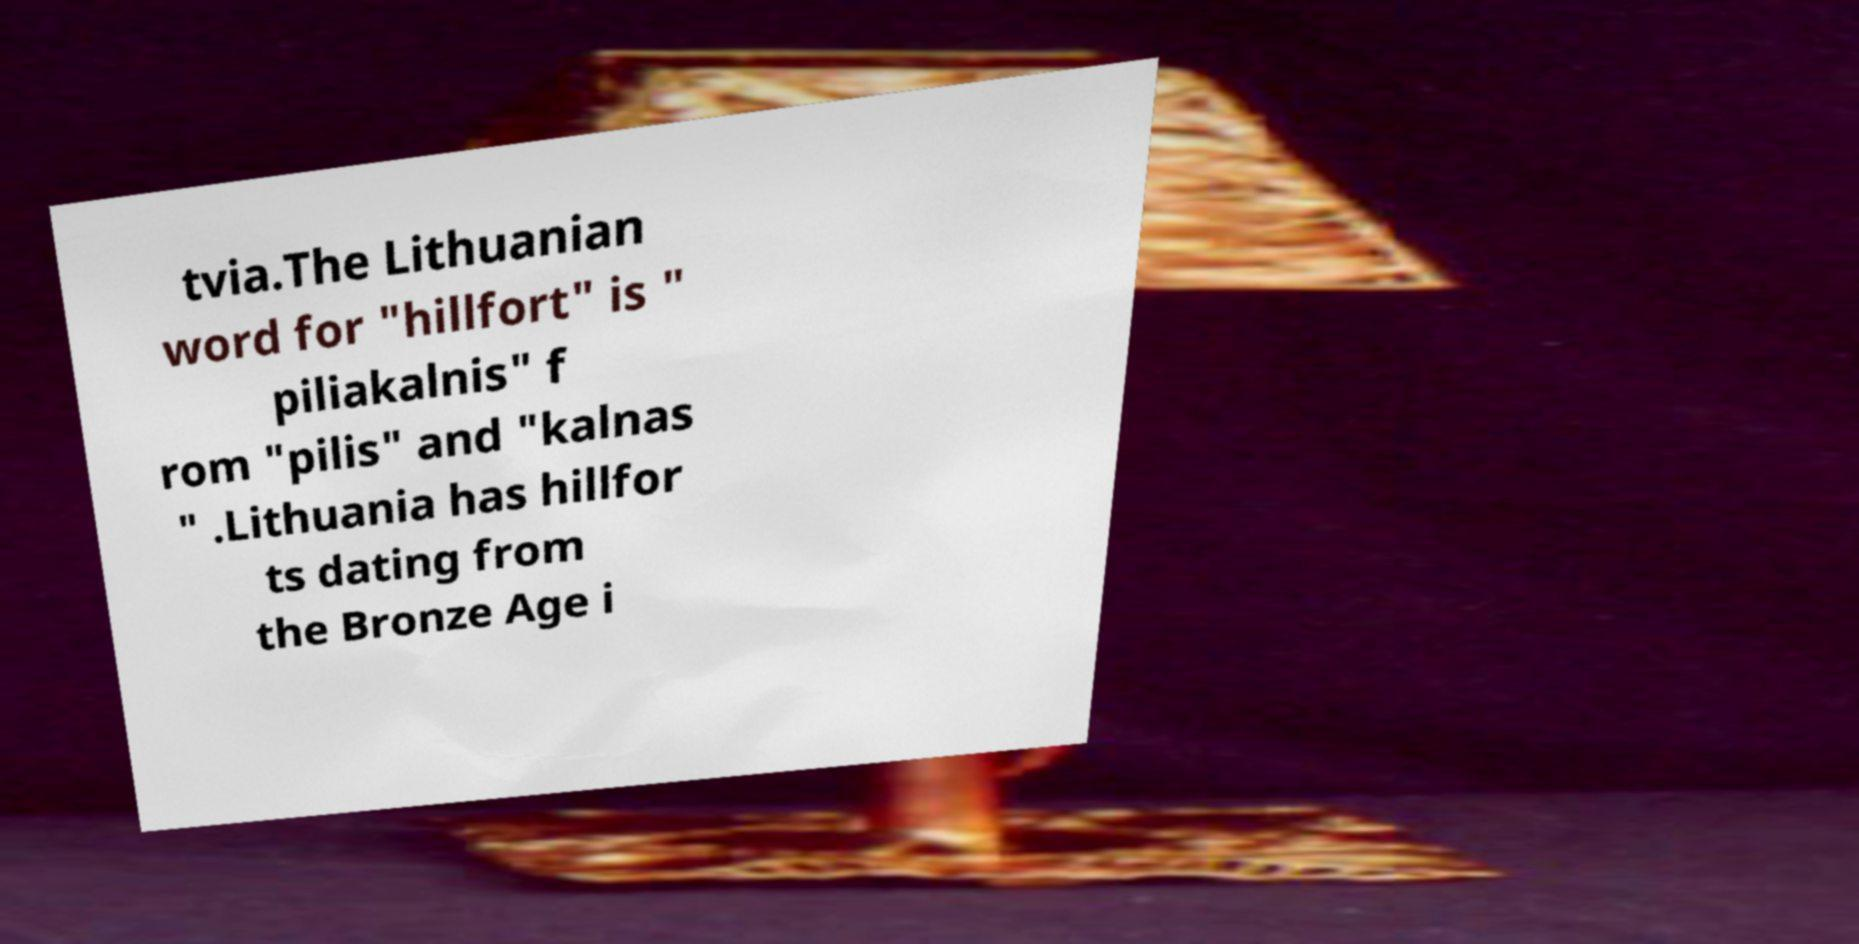Can you accurately transcribe the text from the provided image for me? tvia.The Lithuanian word for "hillfort" is " piliakalnis" f rom "pilis" and "kalnas " .Lithuania has hillfor ts dating from the Bronze Age i 